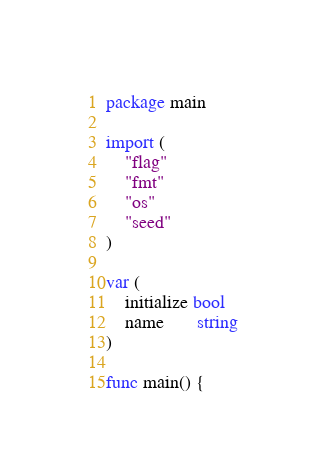<code> <loc_0><loc_0><loc_500><loc_500><_Go_>package main

import (
	"flag"
	"fmt"
	"os"
	"seed"
)

var (
	initialize bool
	name       string
)

func main() {</code> 